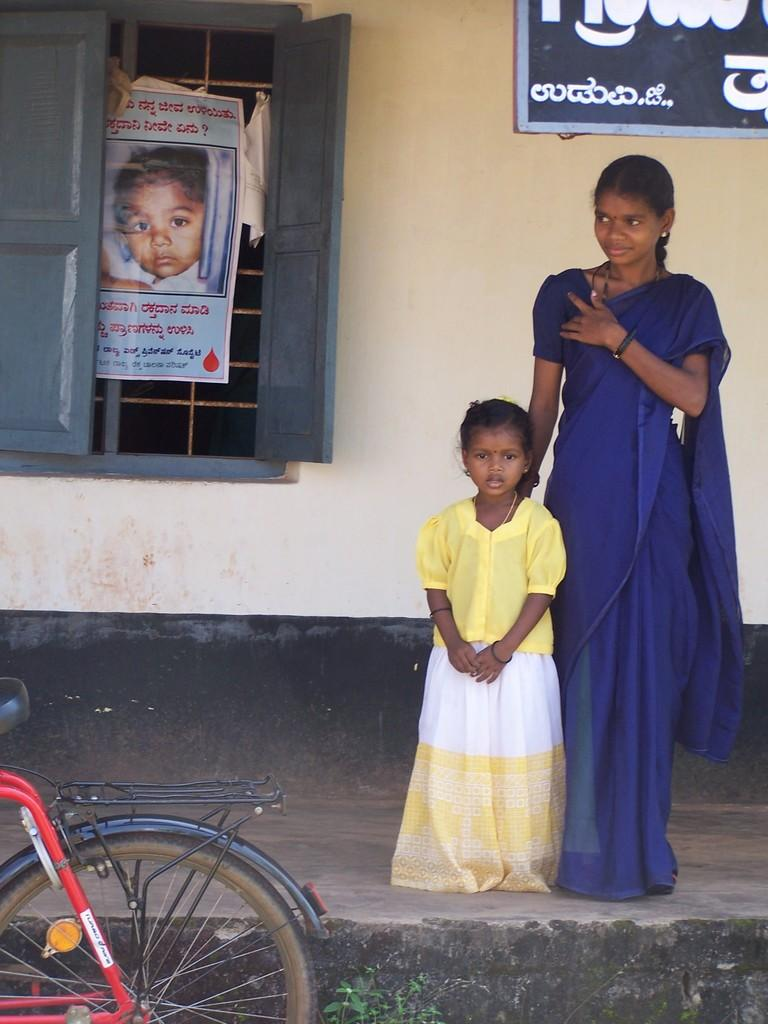Who are the people in the image? There is a woman and a girl in the image. What is on the window in the image? There is a poster on the window. What is on the wall in the image? There is a board on the wall. What objects are in front of the people in the image? There is a bicycle and a plant in front of the people. What type of mint is growing on the woman's leg in the image? There is no mint or any plant growing on the woman's leg in the image. 